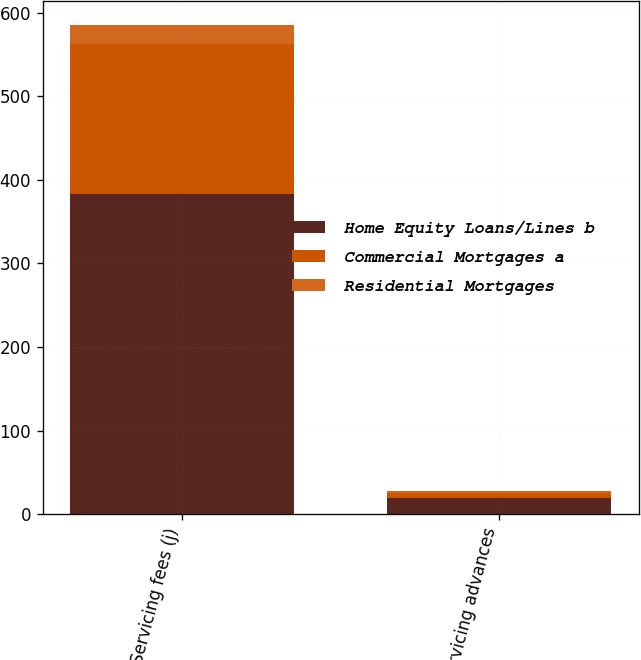Convert chart. <chart><loc_0><loc_0><loc_500><loc_500><stacked_bar_chart><ecel><fcel>Servicing fees (j)<fcel>Servicing advances<nl><fcel>Home Equity Loans/Lines b<fcel>383<fcel>19<nl><fcel>Commercial Mortgages a<fcel>180<fcel>6<nl><fcel>Residential Mortgages<fcel>22<fcel>3<nl></chart> 